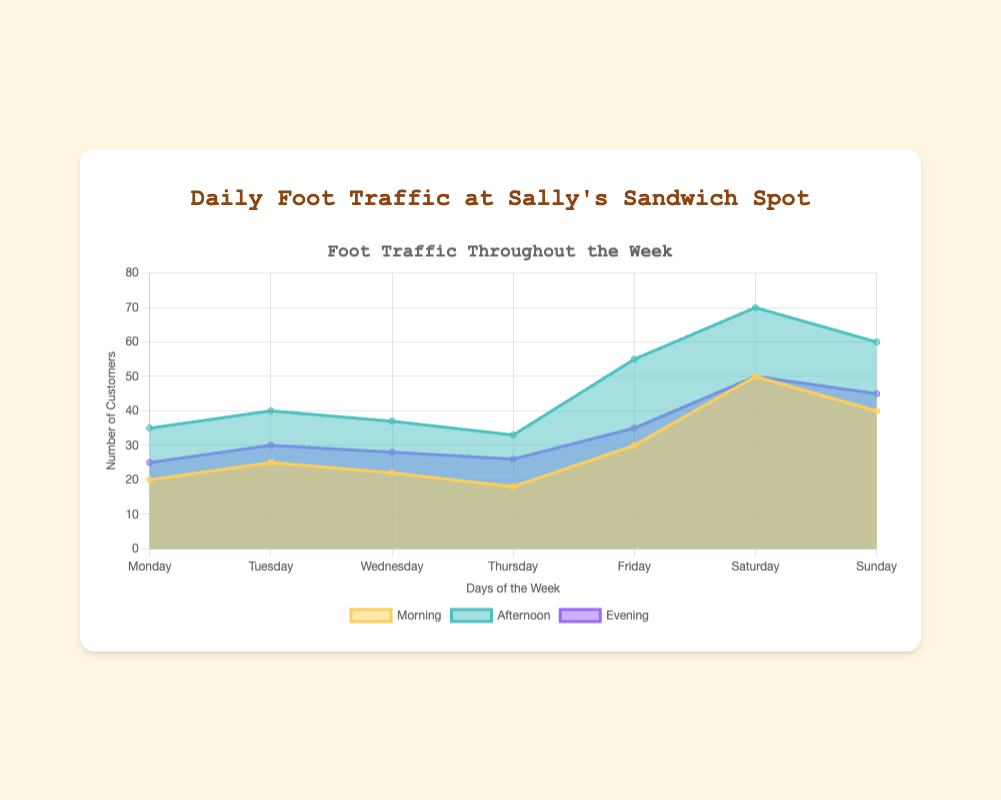What is the highest foot traffic for any time period on any day of the week? To find the highest foot traffic, we need to look for the largest number in the dataset. The highest values are 50 (morning), 70 (afternoon), and 50 (evening). Among these, 70 is the highest.
Answer: 70 On which day does the deli have the lowest foot traffic in the evening? By looking at the evening foot traffic data, the numbers are 25, 30, 28, 26, 35, 50, and 45. The lowest of these values is 25, which occurs on Monday.
Answer: Monday What is the total foot traffic for Saturday across all time periods? Summing up the foot traffic for Saturday in morning (50), afternoon (70), and evening (50), the total is 50 + 70 + 50 = 170.
Answer: 170 Which day sees the highest morning foot traffic? By comparing the morning traffic data, the values are 20, 25, 22, 18, 30, 50, and 40. The highest value is 50, which occurs on Saturday.
Answer: Saturday What's the difference in foot traffic between morning and afternoon on Friday? On Friday, the morning traffic is 30 and the afternoon traffic is 55. The difference is 55 - 30 = 25.
Answer: 25 Compare the foot traffic on Thursday with Sunday. In which time periods does Thursday have more foot traffic than Sunday? On Thursday, the foot traffic is 18 (morning), 33 (afternoon), and 26 (evening). On Sunday, it is 40 (morning), 60 (afternoon), and 45 (evening). Thursday never has higher foot traffic than Sunday on any period.
Answer: None What is the average foot traffic in the afternoon across all days? Summing the afternoon values: 35, 40, 37, 33, 55, 70, and 60, the total is 330. Dividing by 7 (number of days) gives an average of 330 / 7 = ~47.1.
Answer: ~47.1 How does the pattern of foot traffic vary between weekdays and weekends? Weekdays (Monday to Friday) have lower morning and evening foot traffic compared to weekends. The most notable spikes occur during weekends, especially in the afternoon period.
Answer: Higher on weekends Which time period has the most consistent foot traffic across all days? Variance analysis shows that afternoon traffic has the most consistent distribution, ranging between 33 to 70. Morning and evening traffic have more noticeable fluctuations.
Answer: Afternoon 